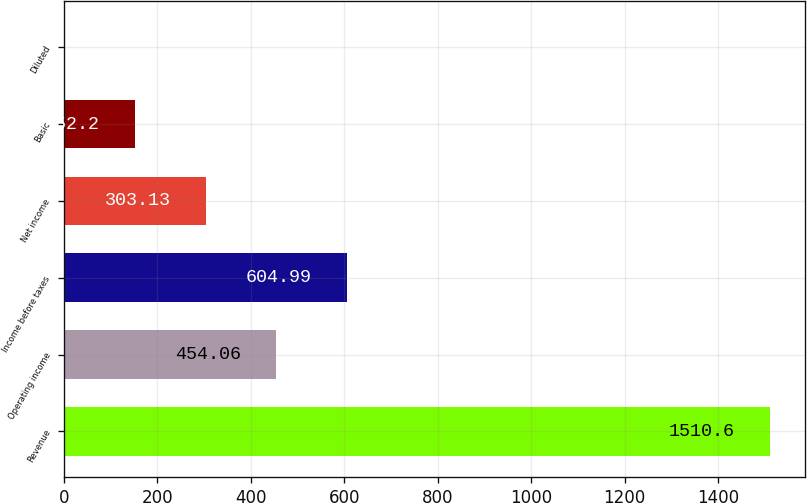Convert chart to OTSL. <chart><loc_0><loc_0><loc_500><loc_500><bar_chart><fcel>Revenue<fcel>Operating income<fcel>Income before taxes<fcel>Net income<fcel>Basic<fcel>Diluted<nl><fcel>1510.6<fcel>454.06<fcel>604.99<fcel>303.13<fcel>152.2<fcel>1.27<nl></chart> 